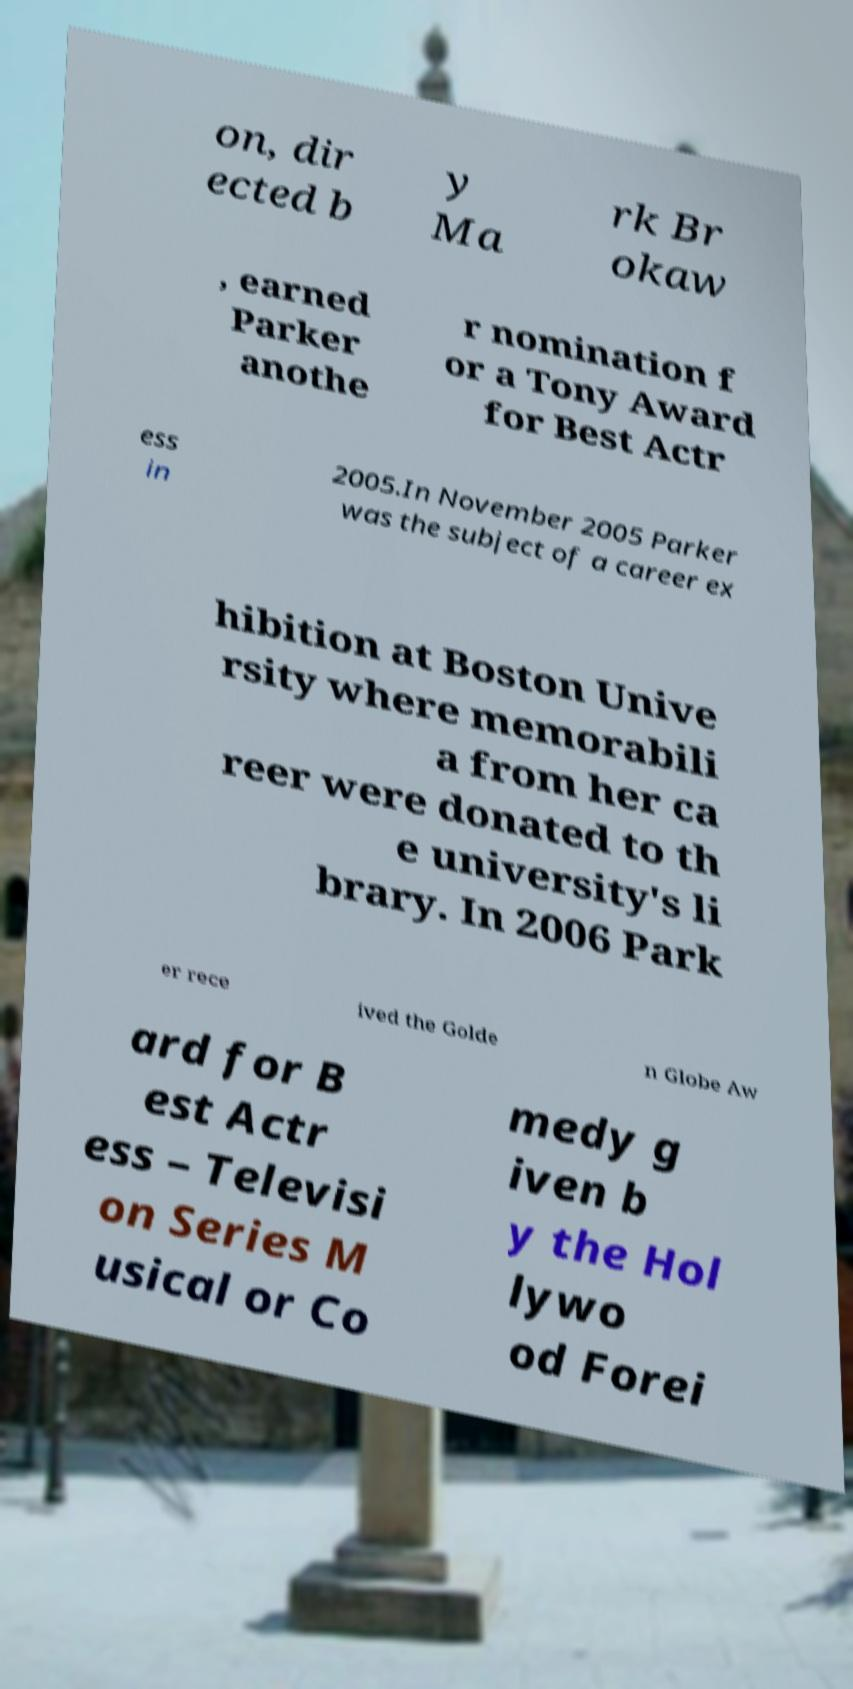I need the written content from this picture converted into text. Can you do that? on, dir ected b y Ma rk Br okaw , earned Parker anothe r nomination f or a Tony Award for Best Actr ess in 2005.In November 2005 Parker was the subject of a career ex hibition at Boston Unive rsity where memorabili a from her ca reer were donated to th e university's li brary. In 2006 Park er rece ived the Golde n Globe Aw ard for B est Actr ess – Televisi on Series M usical or Co medy g iven b y the Hol lywo od Forei 